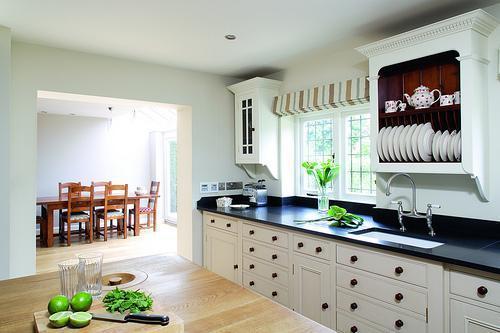How many chairs are facing the far wall?
Give a very brief answer. 2. 